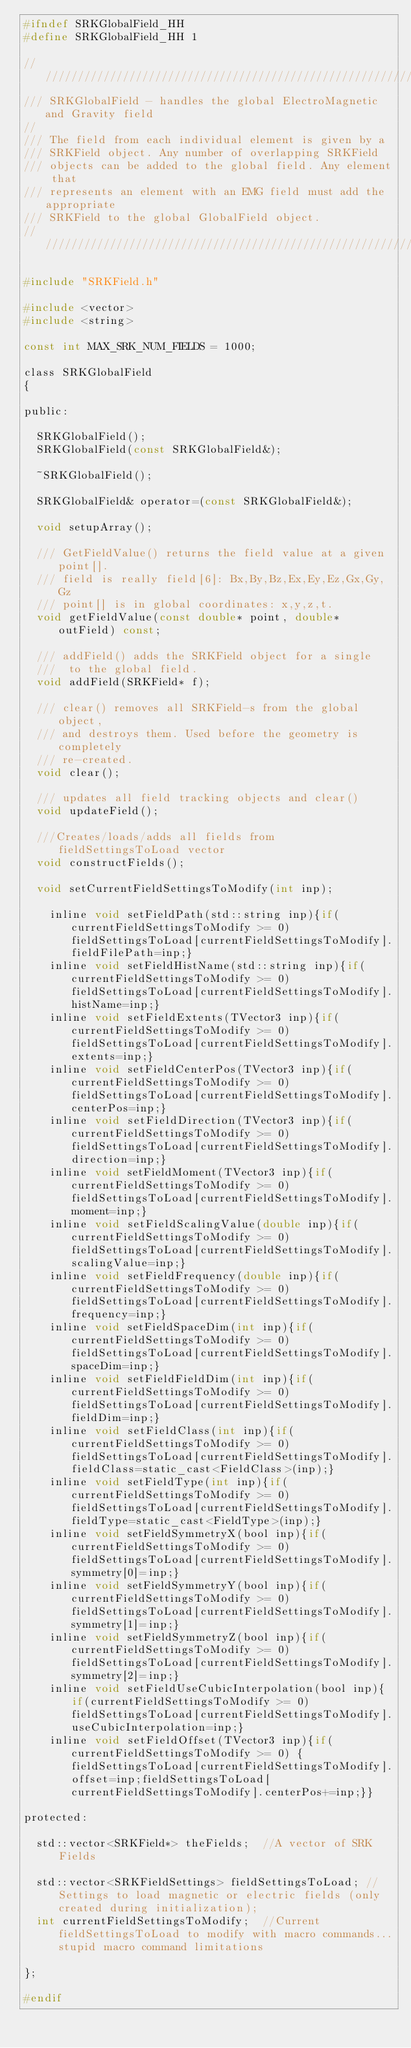Convert code to text. <code><loc_0><loc_0><loc_500><loc_500><_C_>#ifndef SRKGlobalField_HH
#define SRKGlobalField_HH 1

////////////////////////////////////////////////////////////////
/// SRKGlobalField - handles the global ElectroMagnetic and Gravity field
//
/// The field from each individual element is given by a
/// SRKField object. Any number of overlapping SRKField
/// objects can be added to the global field. Any element that
/// represents an element with an EMG field must add the appropriate
/// SRKField to the global GlobalField object.
////////////////////////////////////////////////////////////////

#include "SRKField.h"

#include <vector>
#include <string>

const int MAX_SRK_NUM_FIELDS = 1000;

class SRKGlobalField
{

public:

	SRKGlobalField();
	SRKGlobalField(const SRKGlobalField&);

	~SRKGlobalField();

	SRKGlobalField& operator=(const SRKGlobalField&);

	void setupArray();

	/// GetFieldValue() returns the field value at a given point[].
	/// field is really field[6]: Bx,By,Bz,Ex,Ey,Ez,Gx,Gy,Gz
	/// point[] is in global coordinates: x,y,z,t.
	void getFieldValue(const double* point, double* outField) const;

	/// addField() adds the SRKField object for a single
	///  to the global field.
	void addField(SRKField* f);

	/// clear() removes all SRKField-s from the global object,
	/// and destroys them. Used before the geometry is completely
	/// re-created.
	void clear();

	/// updates all field tracking objects and clear()
	void updateField();

	///Creates/loads/adds all fields from fieldSettingsToLoad vector
	void constructFields();

	void setCurrentFieldSettingsToModify(int inp);

    inline void setFieldPath(std::string inp){if(currentFieldSettingsToModify >= 0) fieldSettingsToLoad[currentFieldSettingsToModify].fieldFilePath=inp;}
    inline void setFieldHistName(std::string inp){if(currentFieldSettingsToModify >= 0) fieldSettingsToLoad[currentFieldSettingsToModify].histName=inp;}
    inline void setFieldExtents(TVector3 inp){if(currentFieldSettingsToModify >= 0) fieldSettingsToLoad[currentFieldSettingsToModify].extents=inp;}
    inline void setFieldCenterPos(TVector3 inp){if(currentFieldSettingsToModify >= 0) fieldSettingsToLoad[currentFieldSettingsToModify].centerPos=inp;}
    inline void setFieldDirection(TVector3 inp){if(currentFieldSettingsToModify >= 0) fieldSettingsToLoad[currentFieldSettingsToModify].direction=inp;}
    inline void setFieldMoment(TVector3 inp){if(currentFieldSettingsToModify >= 0) fieldSettingsToLoad[currentFieldSettingsToModify].moment=inp;}
    inline void setFieldScalingValue(double inp){if(currentFieldSettingsToModify >= 0) fieldSettingsToLoad[currentFieldSettingsToModify].scalingValue=inp;}
    inline void setFieldFrequency(double inp){if(currentFieldSettingsToModify >= 0) fieldSettingsToLoad[currentFieldSettingsToModify].frequency=inp;}
    inline void setFieldSpaceDim(int inp){if(currentFieldSettingsToModify >= 0) fieldSettingsToLoad[currentFieldSettingsToModify].spaceDim=inp;}
    inline void setFieldFieldDim(int inp){if(currentFieldSettingsToModify >= 0) fieldSettingsToLoad[currentFieldSettingsToModify].fieldDim=inp;}
    inline void setFieldClass(int inp){if(currentFieldSettingsToModify >= 0) fieldSettingsToLoad[currentFieldSettingsToModify].fieldClass=static_cast<FieldClass>(inp);}
    inline void setFieldType(int inp){if(currentFieldSettingsToModify >= 0) fieldSettingsToLoad[currentFieldSettingsToModify].fieldType=static_cast<FieldType>(inp);}
    inline void setFieldSymmetryX(bool inp){if(currentFieldSettingsToModify >= 0) fieldSettingsToLoad[currentFieldSettingsToModify].symmetry[0]=inp;}
    inline void setFieldSymmetryY(bool inp){if(currentFieldSettingsToModify >= 0) fieldSettingsToLoad[currentFieldSettingsToModify].symmetry[1]=inp;}
    inline void setFieldSymmetryZ(bool inp){if(currentFieldSettingsToModify >= 0) fieldSettingsToLoad[currentFieldSettingsToModify].symmetry[2]=inp;}
    inline void setFieldUseCubicInterpolation(bool inp){if(currentFieldSettingsToModify >= 0) fieldSettingsToLoad[currentFieldSettingsToModify].useCubicInterpolation=inp;}
    inline void setFieldOffset(TVector3 inp){if(currentFieldSettingsToModify >= 0) {fieldSettingsToLoad[currentFieldSettingsToModify].offset=inp;fieldSettingsToLoad[currentFieldSettingsToModify].centerPos+=inp;}}

protected:

	std::vector<SRKField*> theFields;  //A vector of SRK Fields

	std::vector<SRKFieldSettings> fieldSettingsToLoad; //Settings to load magnetic or electric fields (only created during initialization);
	int currentFieldSettingsToModify;  //Current fieldSettingsToLoad to modify with macro commands...stupid macro command limitations

};

#endif
</code> 